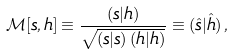Convert formula to latex. <formula><loc_0><loc_0><loc_500><loc_500>\mathcal { M } [ s , h ] \equiv \frac { ( s | h ) } { \sqrt { ( s | s ) \, ( h | h ) } } \equiv ( \hat { s } | \hat { h } ) \, ,</formula> 